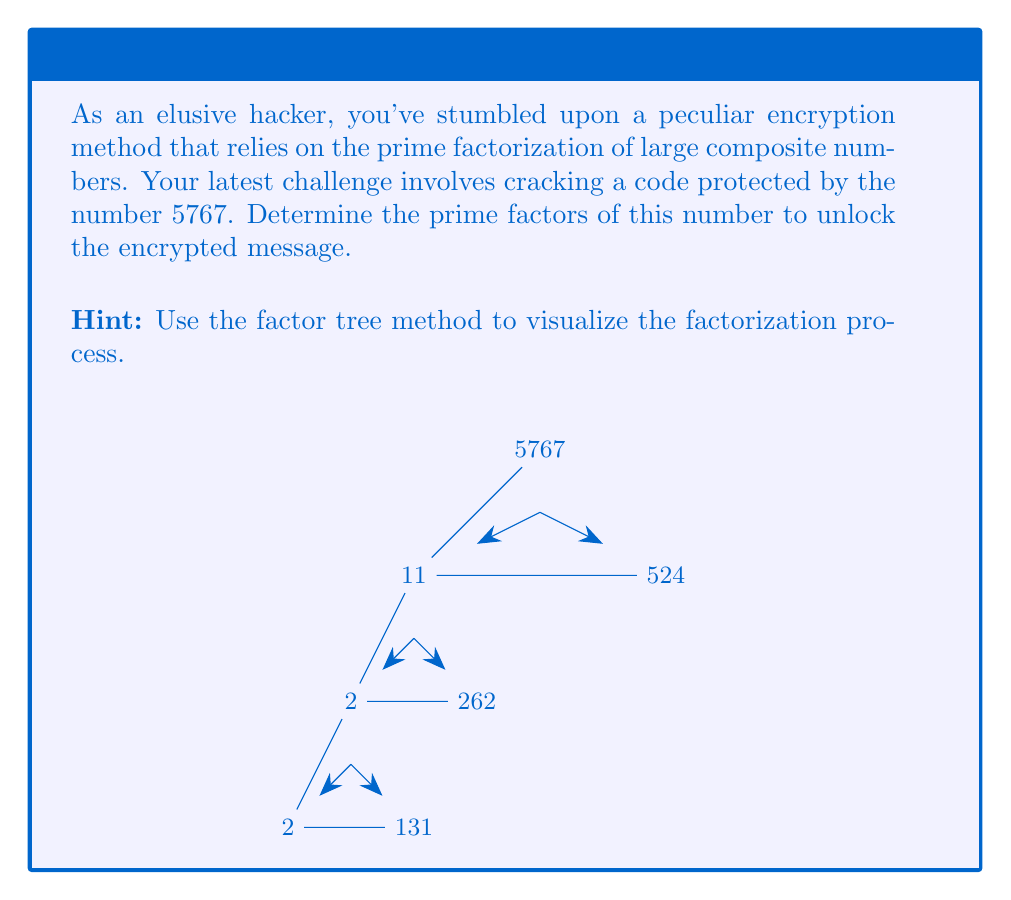Help me with this question. Let's break down the process of finding the prime factors of 5767 step-by-step:

1) First, we need to find the smallest prime factor of 5767. We can start by trying to divide by 2, then 3, 5, 7, and so on until we find a factor.

2) We find that 11 is the smallest prime factor of 5767:
   $$5767 = 11 \times 524$$

3) Now we need to factorize 524. We can see that it's even, so 2 is a factor:
   $$524 = 2 \times 262$$

4) 262 is also even, so we can divide by 2 again:
   $$262 = 2 \times 131$$

5) 131 is a prime number, so we can't factorize it further.

6) Putting all these steps together, we get:
   $$5767 = 11 \times (2 \times 2 \times 131)$$

7) Simplifying and writing in ascending order of prime factors:
   $$5767 = 2^2 \times 11 \times 131$$

This is the prime factorization of 5767. Each of these factors (2, 11, and 131) is prime, and when multiplied together, they equal 5767.
Answer: $2^2 \times 11 \times 131$ 